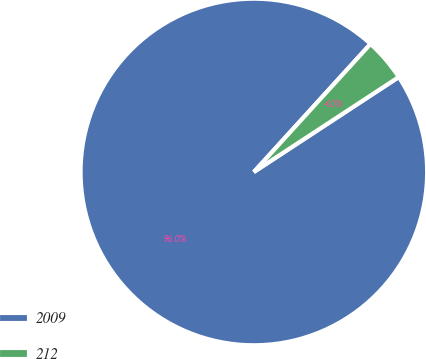<chart> <loc_0><loc_0><loc_500><loc_500><pie_chart><fcel>2009<fcel>212<nl><fcel>95.99%<fcel>4.01%<nl></chart> 